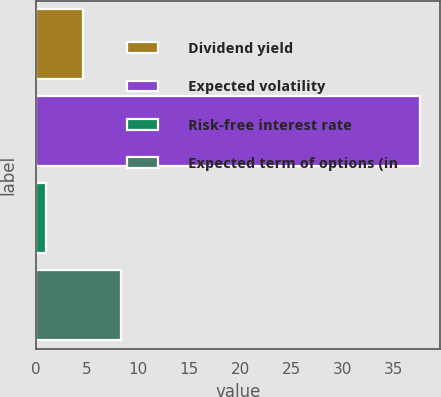Convert chart. <chart><loc_0><loc_0><loc_500><loc_500><bar_chart><fcel>Dividend yield<fcel>Expected volatility<fcel>Risk-free interest rate<fcel>Expected term of options (in<nl><fcel>4.62<fcel>37.65<fcel>0.95<fcel>8.29<nl></chart> 